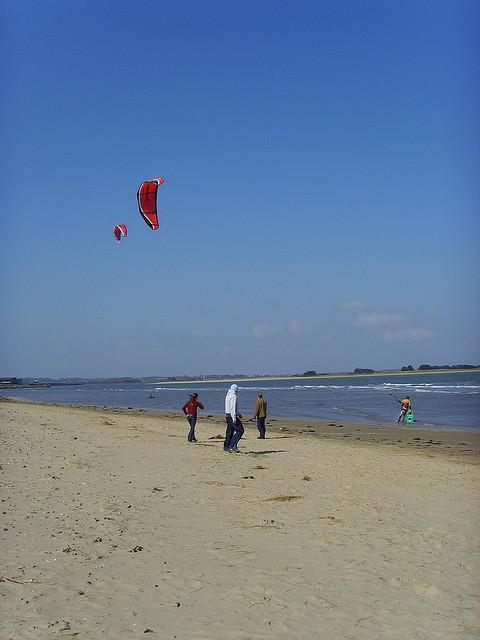What touches the feet of the people holding the airborn sails?
Choose the right answer from the provided options to respond to the question.
Options: Rock, monkeys, water, people. Water. 